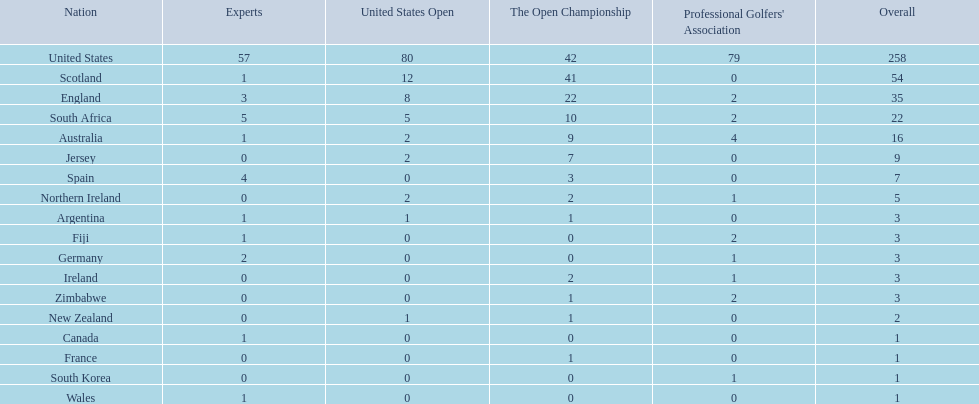Which of the countries listed are african? South Africa, Zimbabwe. Which of those has the least championship winning golfers? Zimbabwe. 